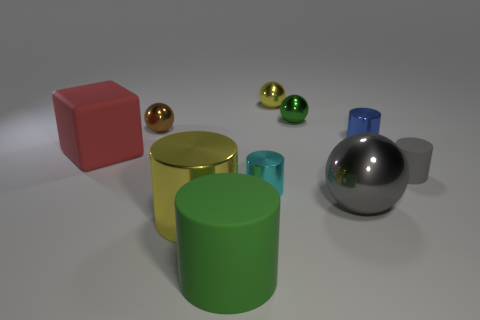What can we deduce about the material properties of the objects based on their appearances? The varying levels of shininess and reflectivity give us clues. The gold and silver spheres, along with the small cyan object, have high reflectivity, indicative of metallic or glass-like materials. The green, red, and grey objects have a matte finish, suggesting a more diffused reflection typical of plastics or ceramics with a less polished surface.  Can you tell if these objects are solid or hollow? Without additional context, it's difficult to definitively say if the objects are solid or hollow. However, the green cylindrical container appears to be hollow given its open top. The spheres and the red cube may be either, as their exteriors don't provide enough information to determine their solidity. 